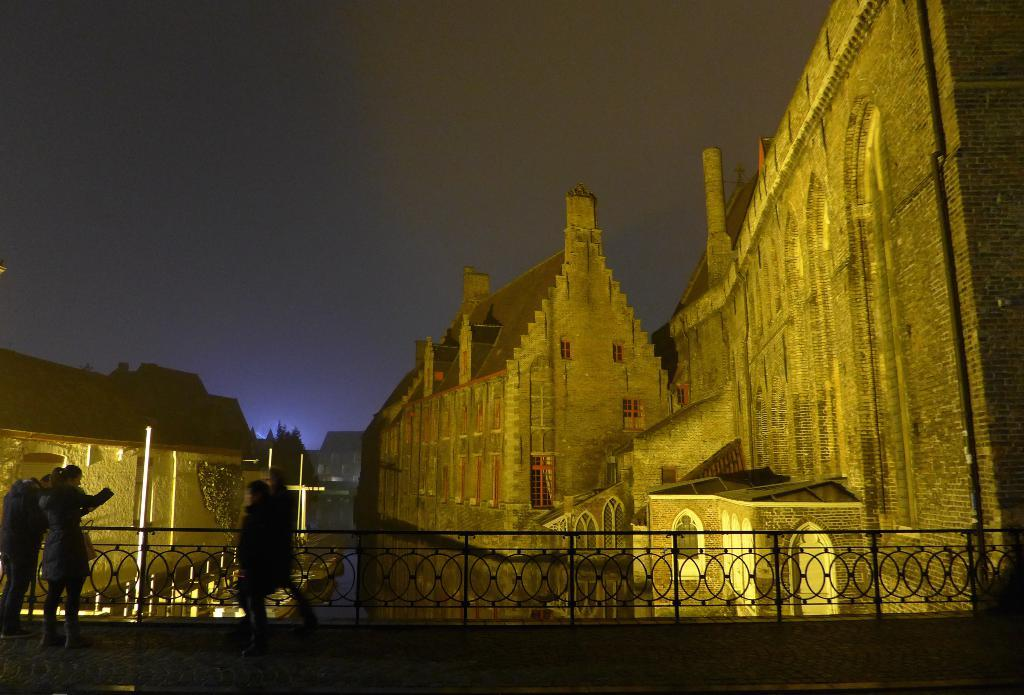What type of building is in the image? There is a brown brick building in the image. What can be seen on the roof of the building? The building has roof tiles. What is in front of the building? There is a metal grill in the front of the building. What is visible at the top of the image? The sky is visible at the top of the image. What type of fight is taking place on the street in the image? There is no fight or street present in the image; it features a brown brick building with roof tiles and a metal grill in front. 